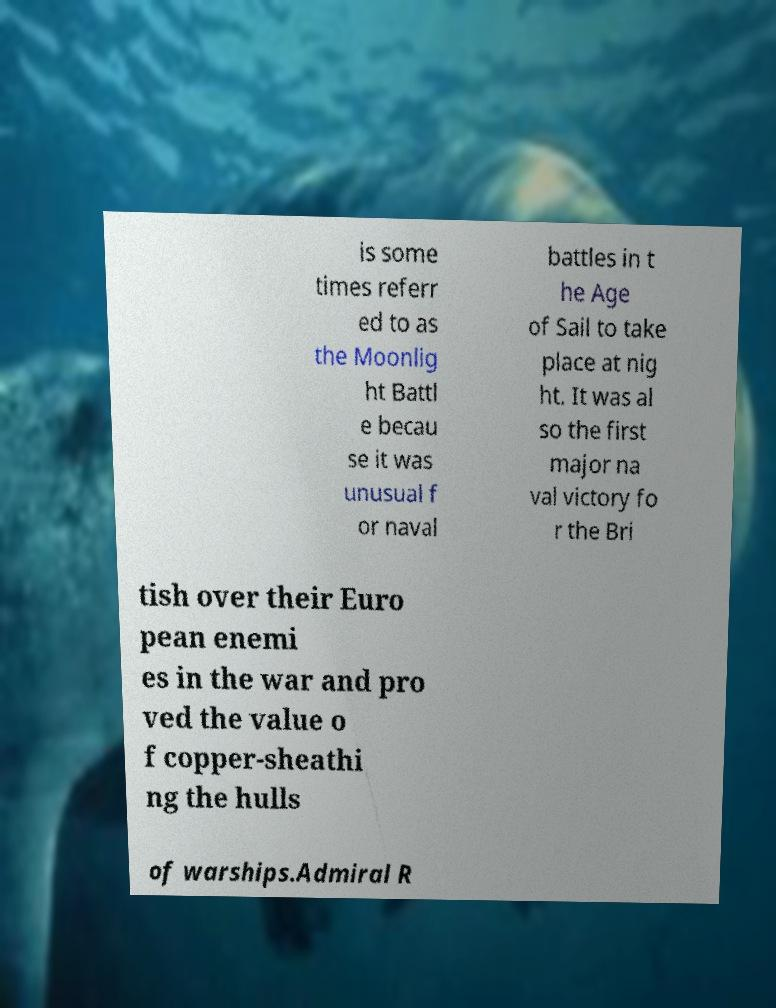I need the written content from this picture converted into text. Can you do that? is some times referr ed to as the Moonlig ht Battl e becau se it was unusual f or naval battles in t he Age of Sail to take place at nig ht. It was al so the first major na val victory fo r the Bri tish over their Euro pean enemi es in the war and pro ved the value o f copper-sheathi ng the hulls of warships.Admiral R 